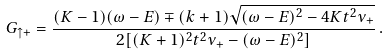Convert formula to latex. <formula><loc_0><loc_0><loc_500><loc_500>G _ { \uparrow + } = \frac { ( K - 1 ) ( \omega - E ) \mp ( k + 1 ) \sqrt { ( \omega - E ) ^ { 2 } - 4 K t ^ { 2 } \nu _ { + } } } { 2 [ ( K + 1 ) ^ { 2 } t ^ { 2 } \nu _ { + } - ( \omega - E ) ^ { 2 } ] } \, .</formula> 